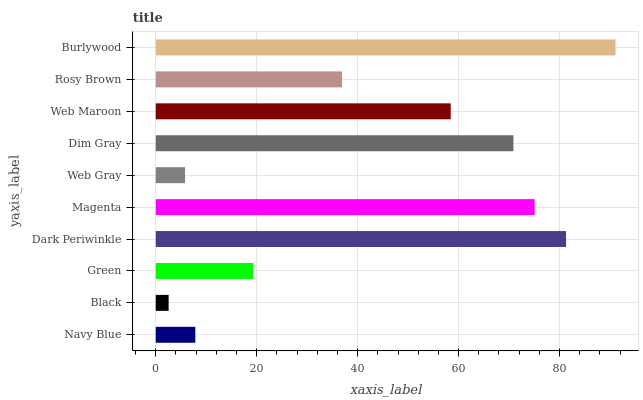Is Black the minimum?
Answer yes or no. Yes. Is Burlywood the maximum?
Answer yes or no. Yes. Is Green the minimum?
Answer yes or no. No. Is Green the maximum?
Answer yes or no. No. Is Green greater than Black?
Answer yes or no. Yes. Is Black less than Green?
Answer yes or no. Yes. Is Black greater than Green?
Answer yes or no. No. Is Green less than Black?
Answer yes or no. No. Is Web Maroon the high median?
Answer yes or no. Yes. Is Rosy Brown the low median?
Answer yes or no. Yes. Is Rosy Brown the high median?
Answer yes or no. No. Is Green the low median?
Answer yes or no. No. 